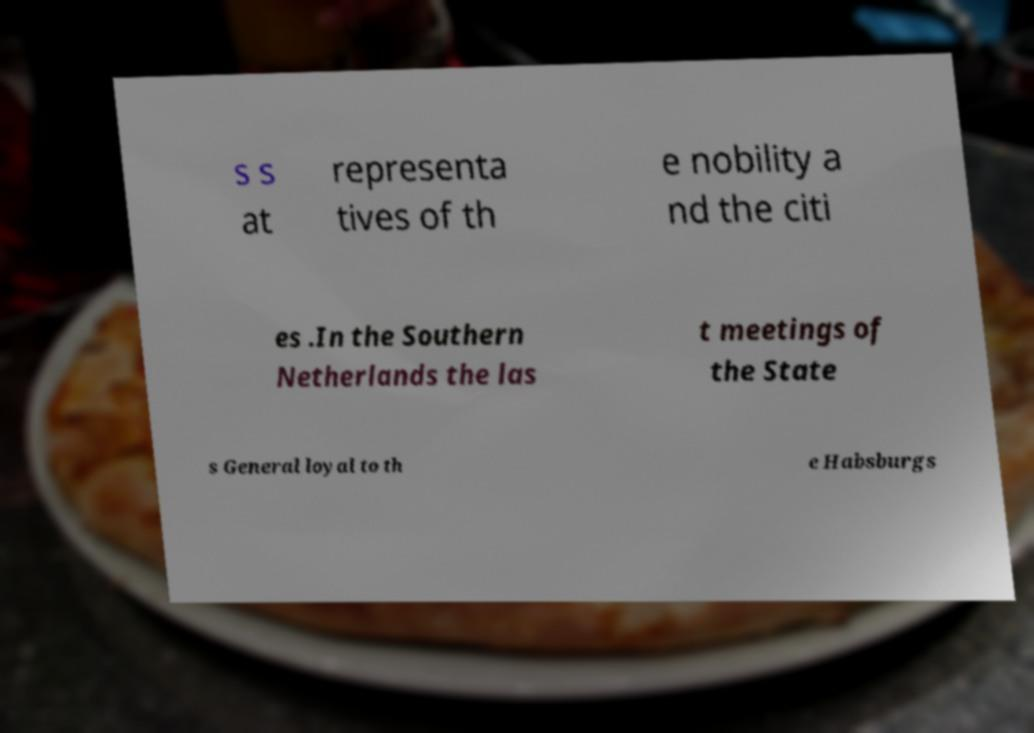For documentation purposes, I need the text within this image transcribed. Could you provide that? s s at representa tives of th e nobility a nd the citi es .In the Southern Netherlands the las t meetings of the State s General loyal to th e Habsburgs 